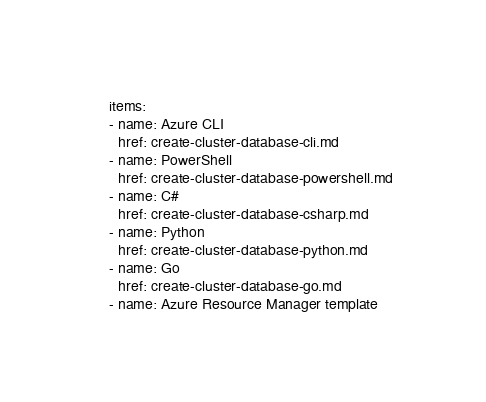<code> <loc_0><loc_0><loc_500><loc_500><_YAML_>    items:
    - name: Azure CLI
      href: create-cluster-database-cli.md
    - name: PowerShell
      href: create-cluster-database-powershell.md
    - name: C#
      href: create-cluster-database-csharp.md
    - name: Python
      href: create-cluster-database-python.md
    - name: Go
      href: create-cluster-database-go.md
    - name: Azure Resource Manager template</code> 